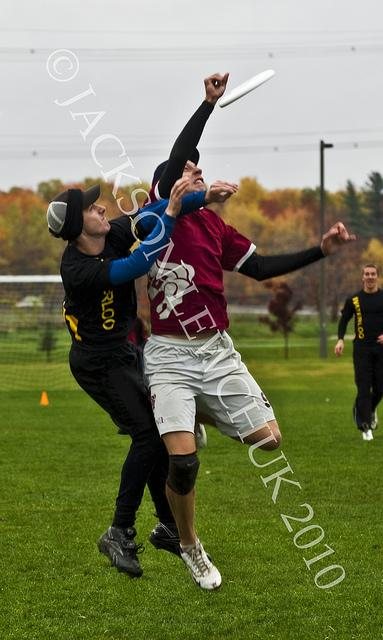What might stop you from using this image in a commercial capacity?

Choices:
A) disturbing nature
B) sexual nature
C) watermark
D) offensive nature watermark 